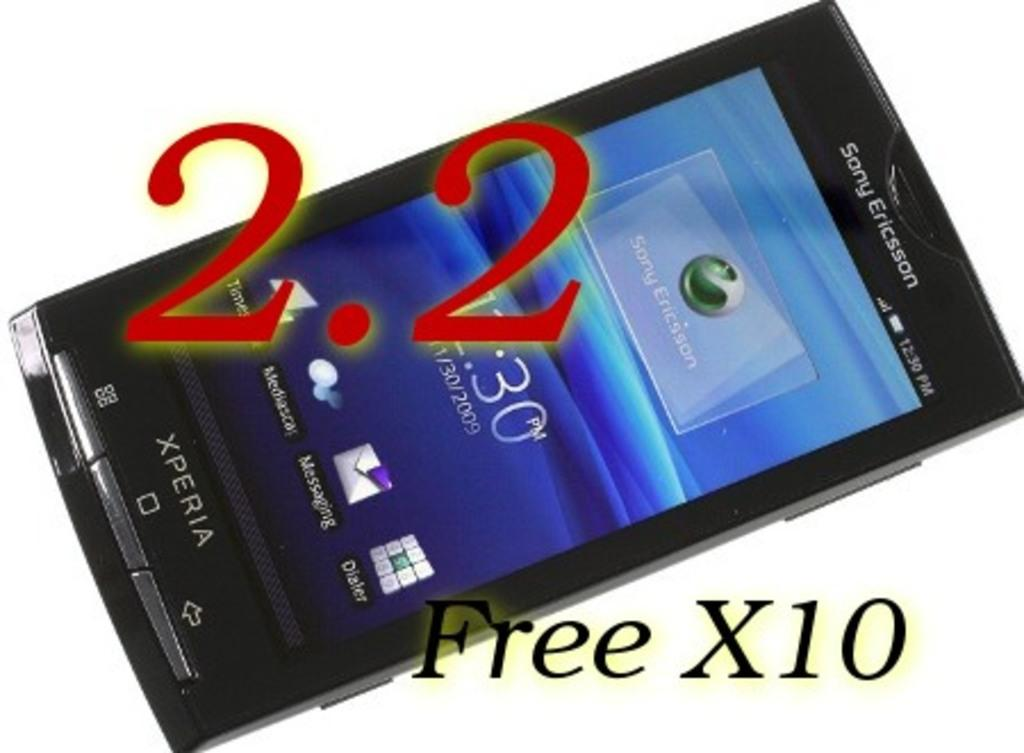<image>
Offer a succinct explanation of the picture presented. a phone next to text that says Free X10 